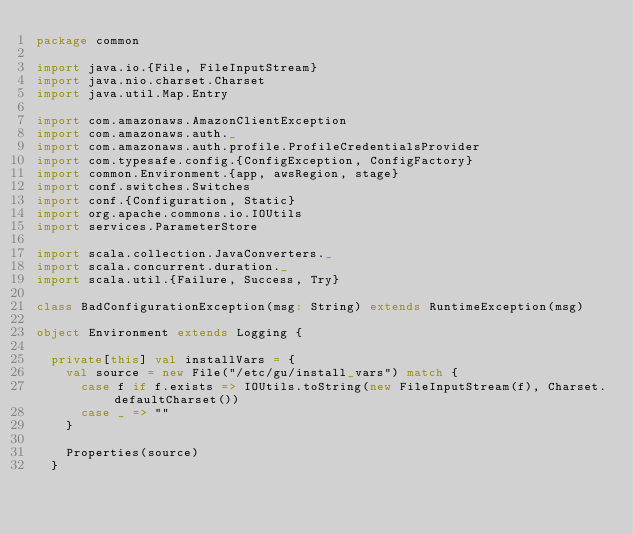<code> <loc_0><loc_0><loc_500><loc_500><_Scala_>package common

import java.io.{File, FileInputStream}
import java.nio.charset.Charset
import java.util.Map.Entry

import com.amazonaws.AmazonClientException
import com.amazonaws.auth._
import com.amazonaws.auth.profile.ProfileCredentialsProvider
import com.typesafe.config.{ConfigException, ConfigFactory}
import common.Environment.{app, awsRegion, stage}
import conf.switches.Switches
import conf.{Configuration, Static}
import org.apache.commons.io.IOUtils
import services.ParameterStore

import scala.collection.JavaConverters._
import scala.concurrent.duration._
import scala.util.{Failure, Success, Try}

class BadConfigurationException(msg: String) extends RuntimeException(msg)

object Environment extends Logging {

  private[this] val installVars = {
    val source = new File("/etc/gu/install_vars") match {
      case f if f.exists => IOUtils.toString(new FileInputStream(f), Charset.defaultCharset())
      case _ => ""
    }

    Properties(source)
  }
</code> 